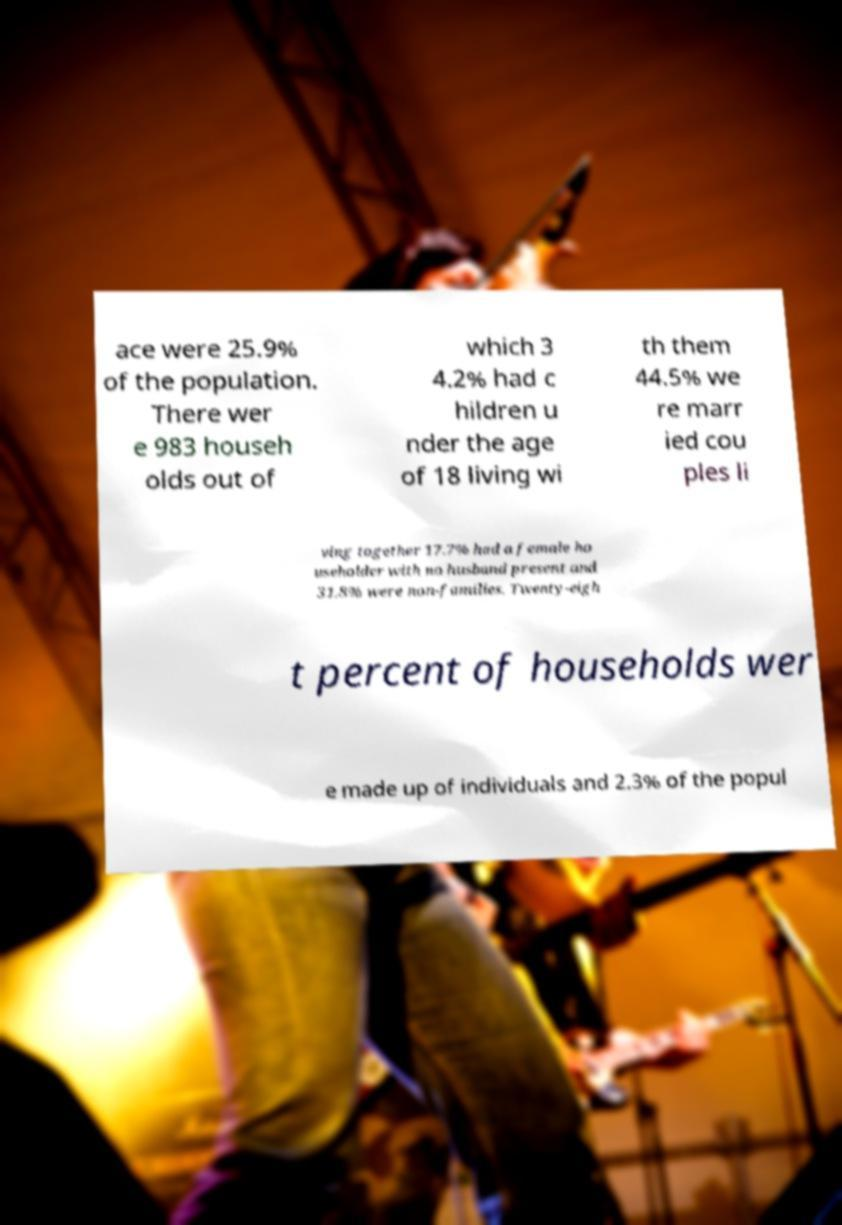There's text embedded in this image that I need extracted. Can you transcribe it verbatim? ace were 25.9% of the population. There wer e 983 househ olds out of which 3 4.2% had c hildren u nder the age of 18 living wi th them 44.5% we re marr ied cou ples li ving together 17.7% had a female ho useholder with no husband present and 31.8% were non-families. Twenty-eigh t percent of households wer e made up of individuals and 2.3% of the popul 